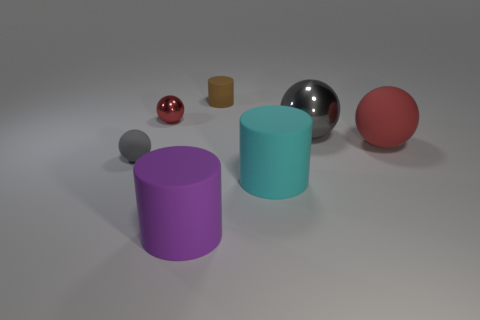Do the tiny thing in front of the small red shiny thing and the red object that is right of the small shiny ball have the same shape?
Keep it short and to the point. Yes. What is the shape of the red thing that is to the right of the large rubber cylinder that is behind the big purple matte cylinder?
Make the answer very short. Sphere. What size is the metallic sphere that is the same color as the large rubber ball?
Provide a succinct answer. Small. Are there any purple cylinders that have the same material as the big gray thing?
Make the answer very short. No. What material is the red object on the left side of the large purple thing?
Give a very brief answer. Metal. What material is the large gray thing?
Give a very brief answer. Metal. Is the material of the gray thing on the left side of the red metallic object the same as the small red sphere?
Your answer should be compact. No. Is the number of big red balls behind the purple rubber cylinder less than the number of gray rubber spheres?
Keep it short and to the point. No. There is another matte thing that is the same size as the brown rubber object; what color is it?
Give a very brief answer. Gray. What number of tiny brown rubber objects are the same shape as the gray matte thing?
Make the answer very short. 0. 